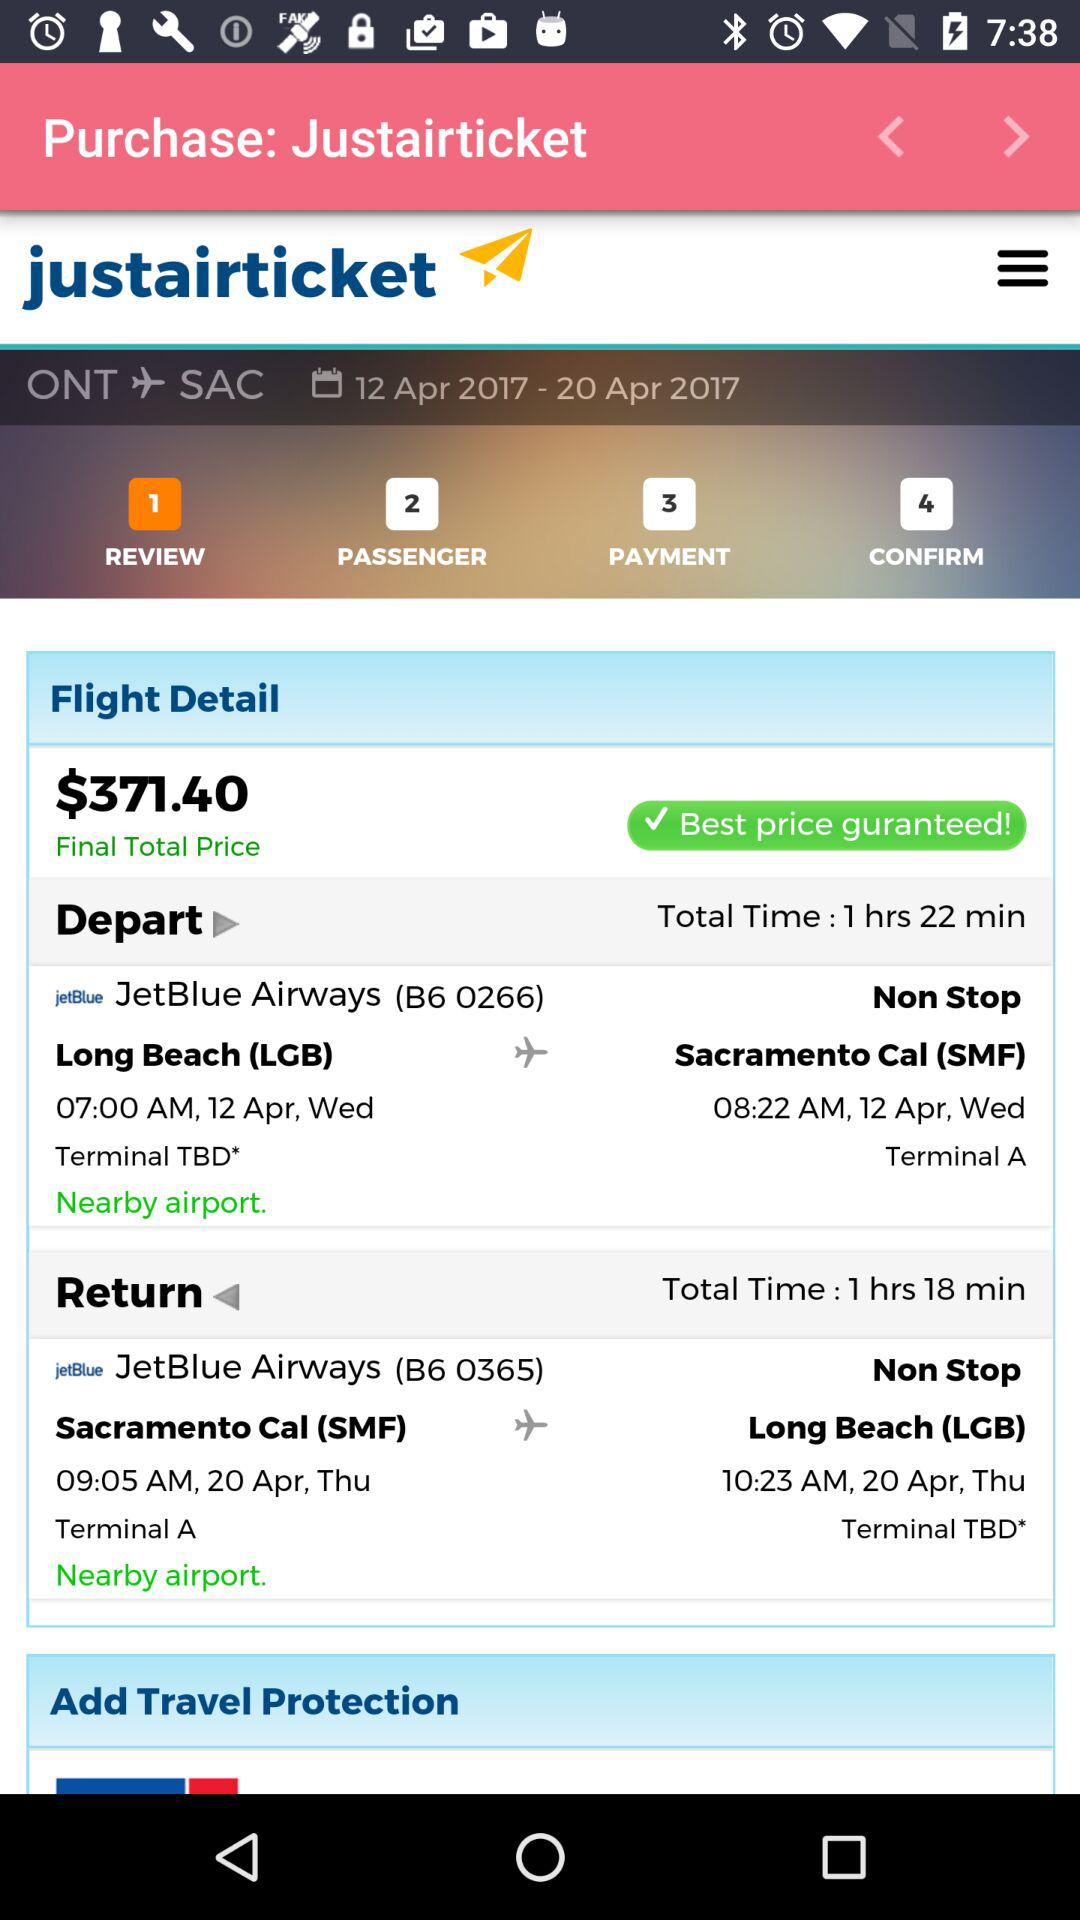What is the name of the airways? The name of the airways is "JetBlue". 